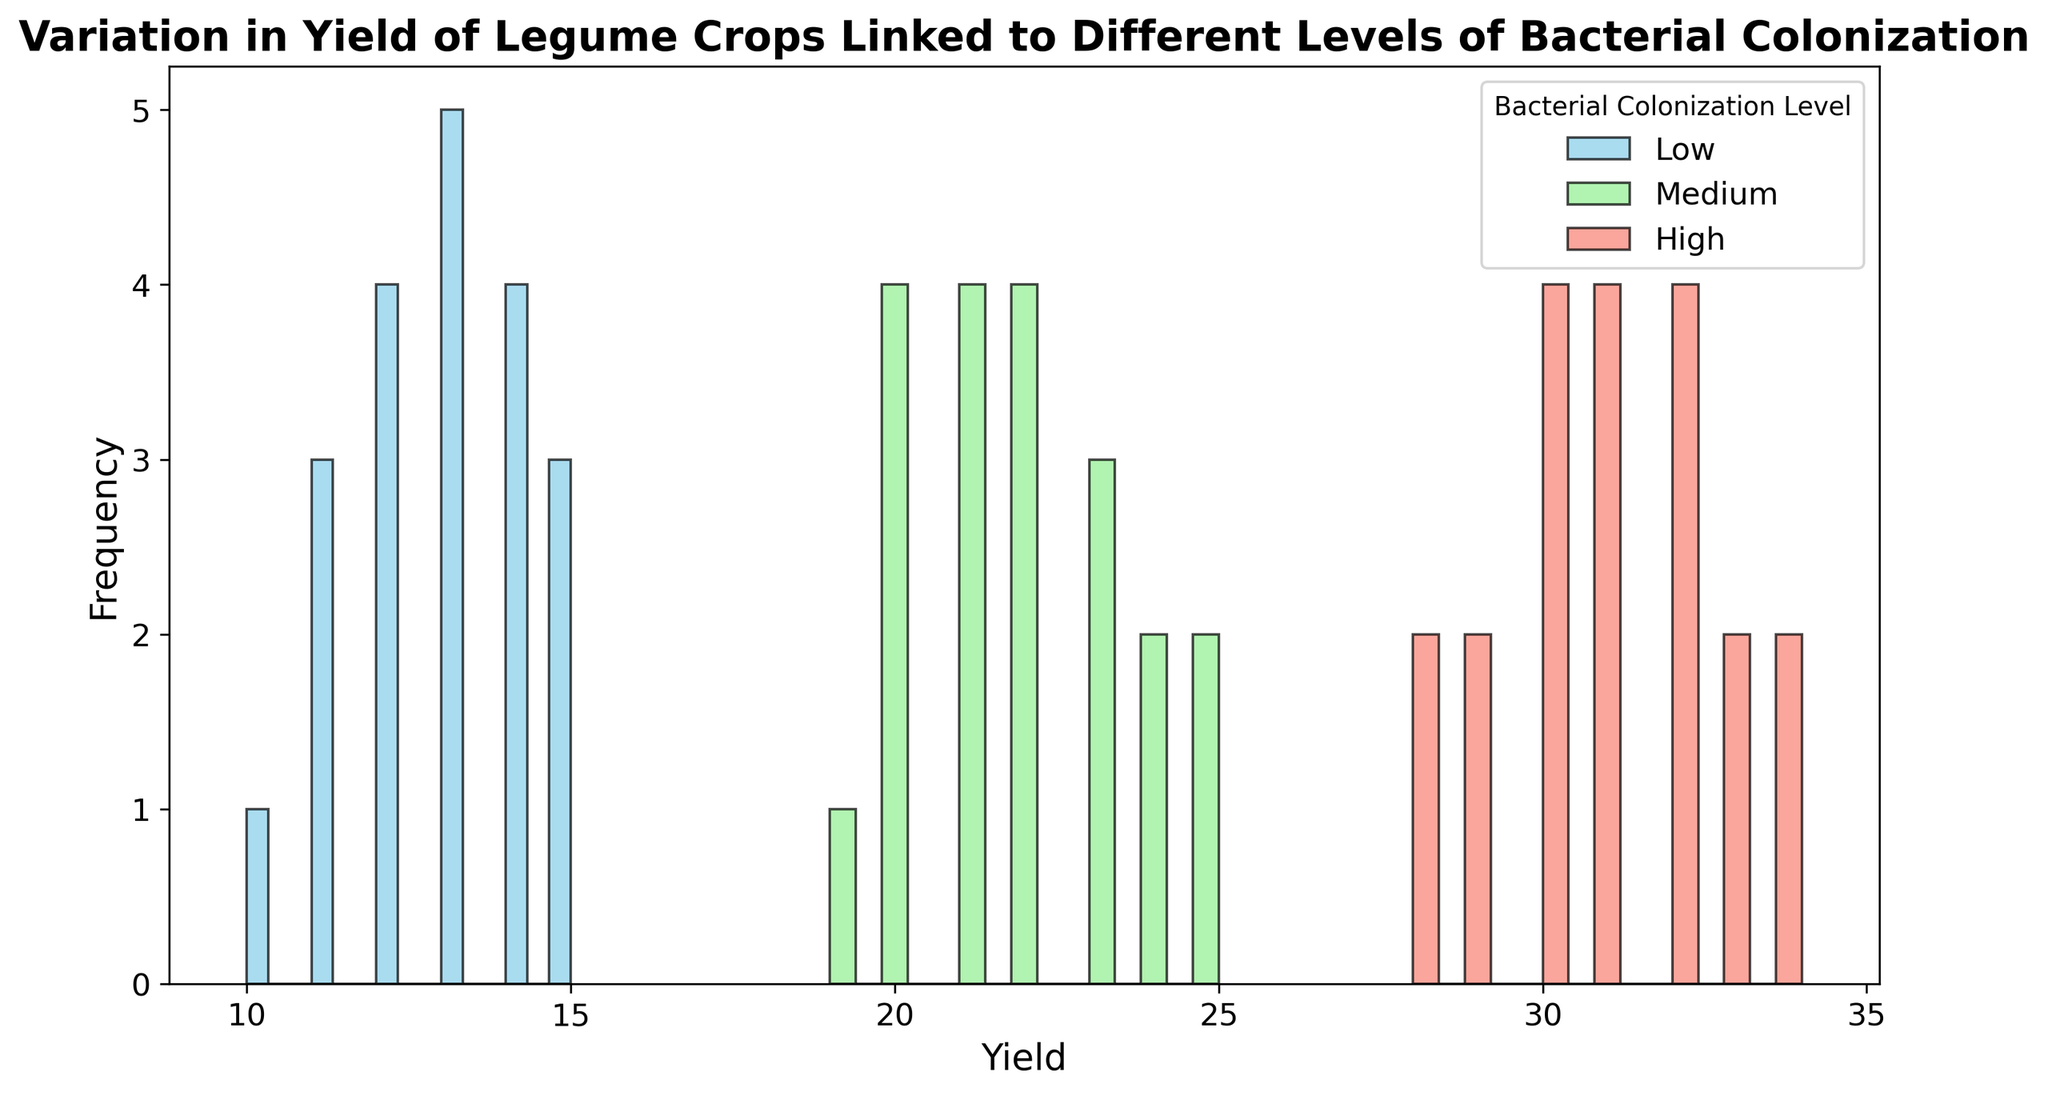What is the most frequent yield value for crops with high bacterial colonization? By looking at the histogram bars, we can identify which yield value appears most frequently for the crops with high bacterial colonization.
Answer: 30 How does the range of yields for crops with low bacterial colonization compare to the range for crops with high bacterial colonization? To compare the ranges, we need to note the minimum and maximum yield values for each group. For low colonization, the yields range from 10 to 15, while for high colonization, the yields range from 28 to 34.
Answer: The range is smaller for low colonization (5) compared to high colonization (6) What is the median yield for crops with medium bacterial colonization? To find the median, we need to arrange the yield values for medium bacterial colonization in order and find the middle value. Since there are 15 values, we find the 8th value in the sorted list.
Answer: 22 Between which two yield values does the highest frequency of yields for crops with medium bacterial colonization fall? By examining the histogram for medium bacterial colonization, we see which bin has the tallest bar, signifying the highest frequency. This range is between 20 and 25.
Answer: 20 and 25 Is there any overlap in yield values across the different levels of bacterial colonization? To determine overlap, we observe whether any yield values appear in more than one group. Yields in the 11 to 15 range overlap between low and medium colonization, and those in the 28 to 32 range overlap between medium and high colonization.
Answer: Yes Which bacterial colonization level has the most spread-out distribution of yields? By assessing the histograms for each colonization level, we look for the one with the widest range. Although all groups have unique traits, the low colonization level appears to have a narrower range compared to the others, while medium seems less spread out than high.
Answer: High 